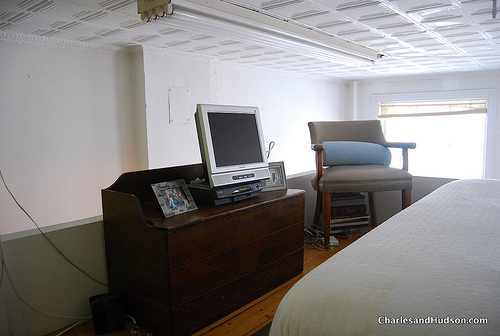Is the TV to the left of a girl? No, the television is placed to the left of the dresser, not in relation to a girl. 